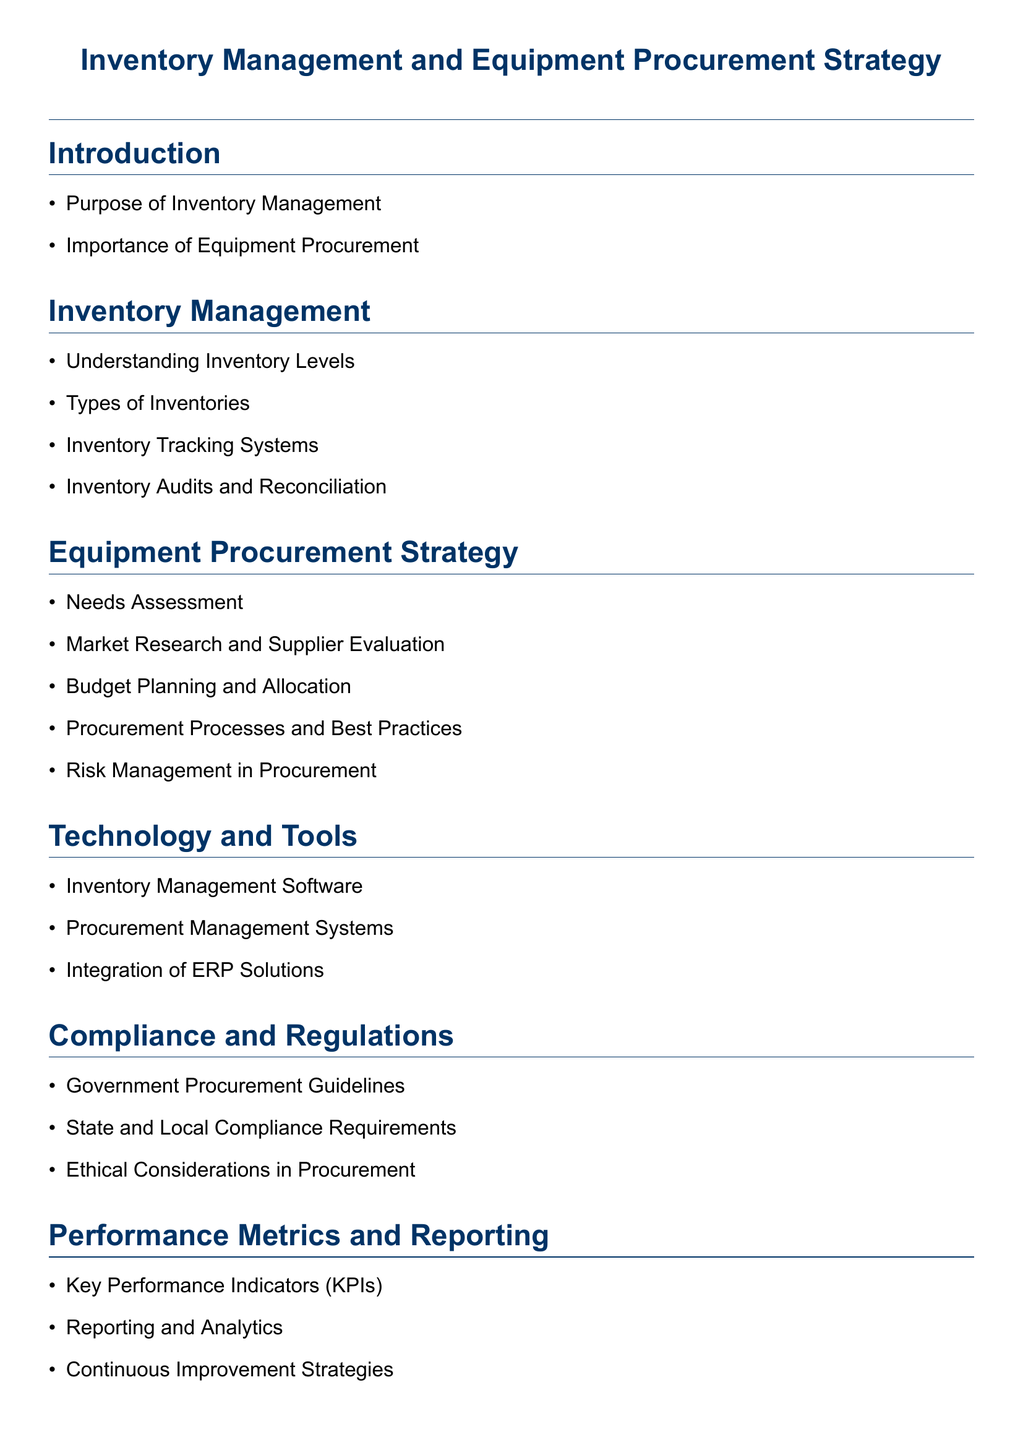What is the main focus of the document? The document focuses on inventory management and equipment procurement strategy within the police department context.
Answer: Inventory Management and Equipment Procurement Strategy How many sections are in the document? The document contains a total of seven sections including the introduction and conclusion.
Answer: Seven What is discussed under Equipment Procurement Strategy? The Equipment Procurement Strategy section includes needs assessment, market research, budget planning, procurement processes, and risk management.
Answer: Needs Assessment, Market Research and Supplier Evaluation, Budget Planning and Allocation, Procurement Processes and Best Practices, Risk Management in Procurement What type of software is mentioned in the Technology and Tools section? The Technology and Tools section mentions inventory management software as part of the tools available for managing inventory.
Answer: Inventory Management Software What is one compliance requirement noted in the document? The Compliance and Regulations section refers to government procurement guidelines as a key requirement for procurement activities.
Answer: Government Procurement Guidelines What are KPIs related to in the document? KPIs are key performance indicators mentioned in the Performance Metrics and Reporting section that help measure success in inventory and procurement efforts.
Answer: Key Performance Indicators What does the conclusion summarize? The conclusion summarizes the key points discussed throughout the document and highlights future trends in inventory and procurement management.
Answer: Summary of Key Points What is a challenge mentioned in the Case Studies section? The Case Studies section discusses challenges and resolutions in overall inventory management as a key point of analysis.
Answer: Challenges and Resolutions in Inventory Management 